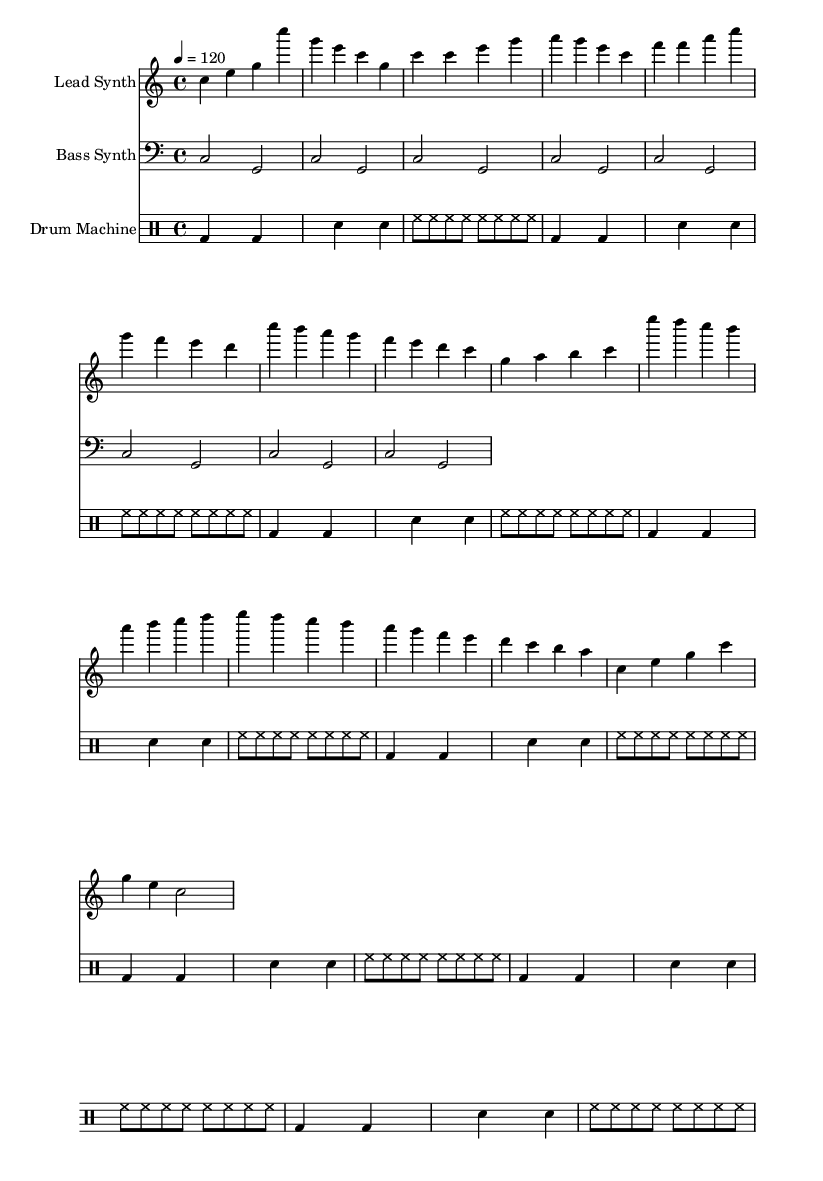What is the key signature of this music? The key signature is indicated at the beginning of the staff and shows C major, which has no sharps or flats.
Answer: C major What is the time signature of this music? The time signature is found at the beginning of the score and indicates the number of beats per measure, which is 4/4, meaning four beats in each measure.
Answer: 4/4 What is the tempo marking for this piece? The tempo marking is present in the "global" section and sets the speed of the piece. It indicates a tempo of quarter note equals 120 beats per minute.
Answer: 120 How many measures are in the lead synth part? To find the number of measures, one must count the segments separated by vertical bar lines in the lead synth staff. There are 16 measures in total.
Answer: 16 Which instrument has a bass clef? The bass clef is indicated in the second staff of the score, which is labeled "Bass Synth," confirming it is assigned to this instrument.
Answer: Bass Synth What section follows the chorus in the lead synth part? The structure includes a clearly labeled "Bridge" section, which directly follows the chorus. This can be identified by the specific notes and titles in the lead synth part.
Answer: Bridge What type of drum beats does the drum machine use? The drum machine is notated in a specific rhythmic pattern which includes bass drum, snare drum, and hi-hat. The consistent use of bass drum and hi-hat indicates a standard dance beat style.
Answer: Dance beat 